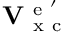<formula> <loc_0><loc_0><loc_500><loc_500>V _ { x c } ^ { e ^ { \prime } }</formula> 